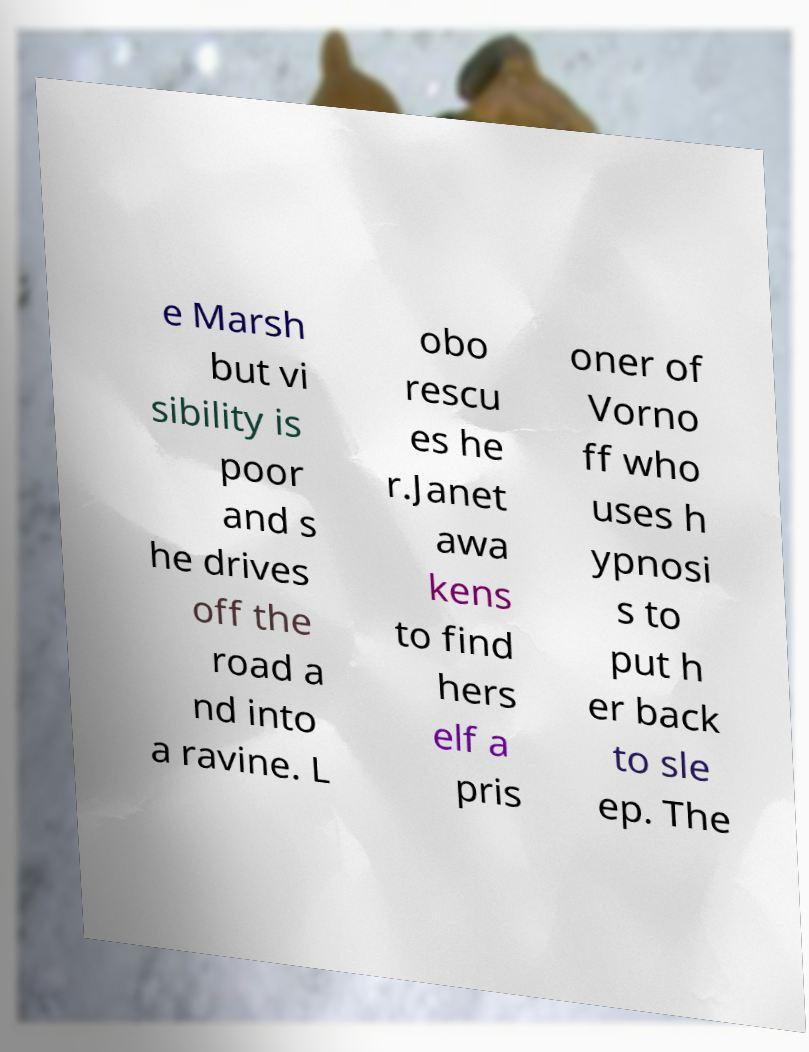Could you extract and type out the text from this image? e Marsh but vi sibility is poor and s he drives off the road a nd into a ravine. L obo rescu es he r.Janet awa kens to find hers elf a pris oner of Vorno ff who uses h ypnosi s to put h er back to sle ep. The 